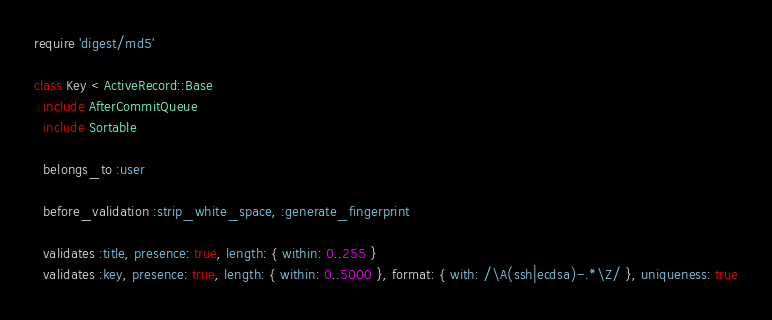Convert code to text. <code><loc_0><loc_0><loc_500><loc_500><_Ruby_>require 'digest/md5'

class Key < ActiveRecord::Base
  include AfterCommitQueue
  include Sortable

  belongs_to :user

  before_validation :strip_white_space, :generate_fingerprint

  validates :title, presence: true, length: { within: 0..255 }
  validates :key, presence: true, length: { within: 0..5000 }, format: { with: /\A(ssh|ecdsa)-.*\Z/ }, uniqueness: true</code> 